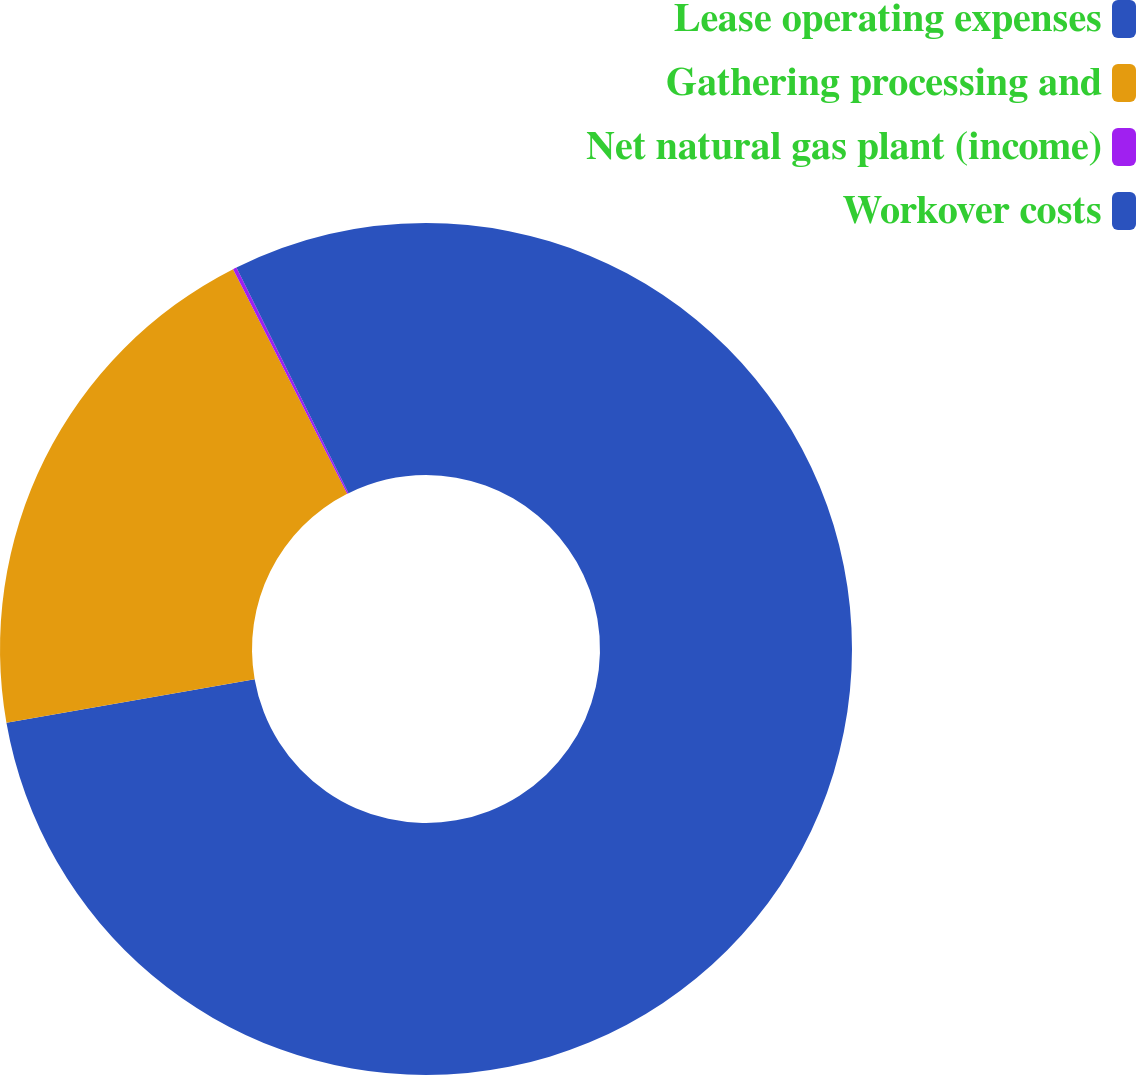Convert chart to OTSL. <chart><loc_0><loc_0><loc_500><loc_500><pie_chart><fcel>Lease operating expenses<fcel>Gathering processing and<fcel>Net natural gas plant (income)<fcel>Workover costs<nl><fcel>72.23%<fcel>20.29%<fcel>0.14%<fcel>7.34%<nl></chart> 